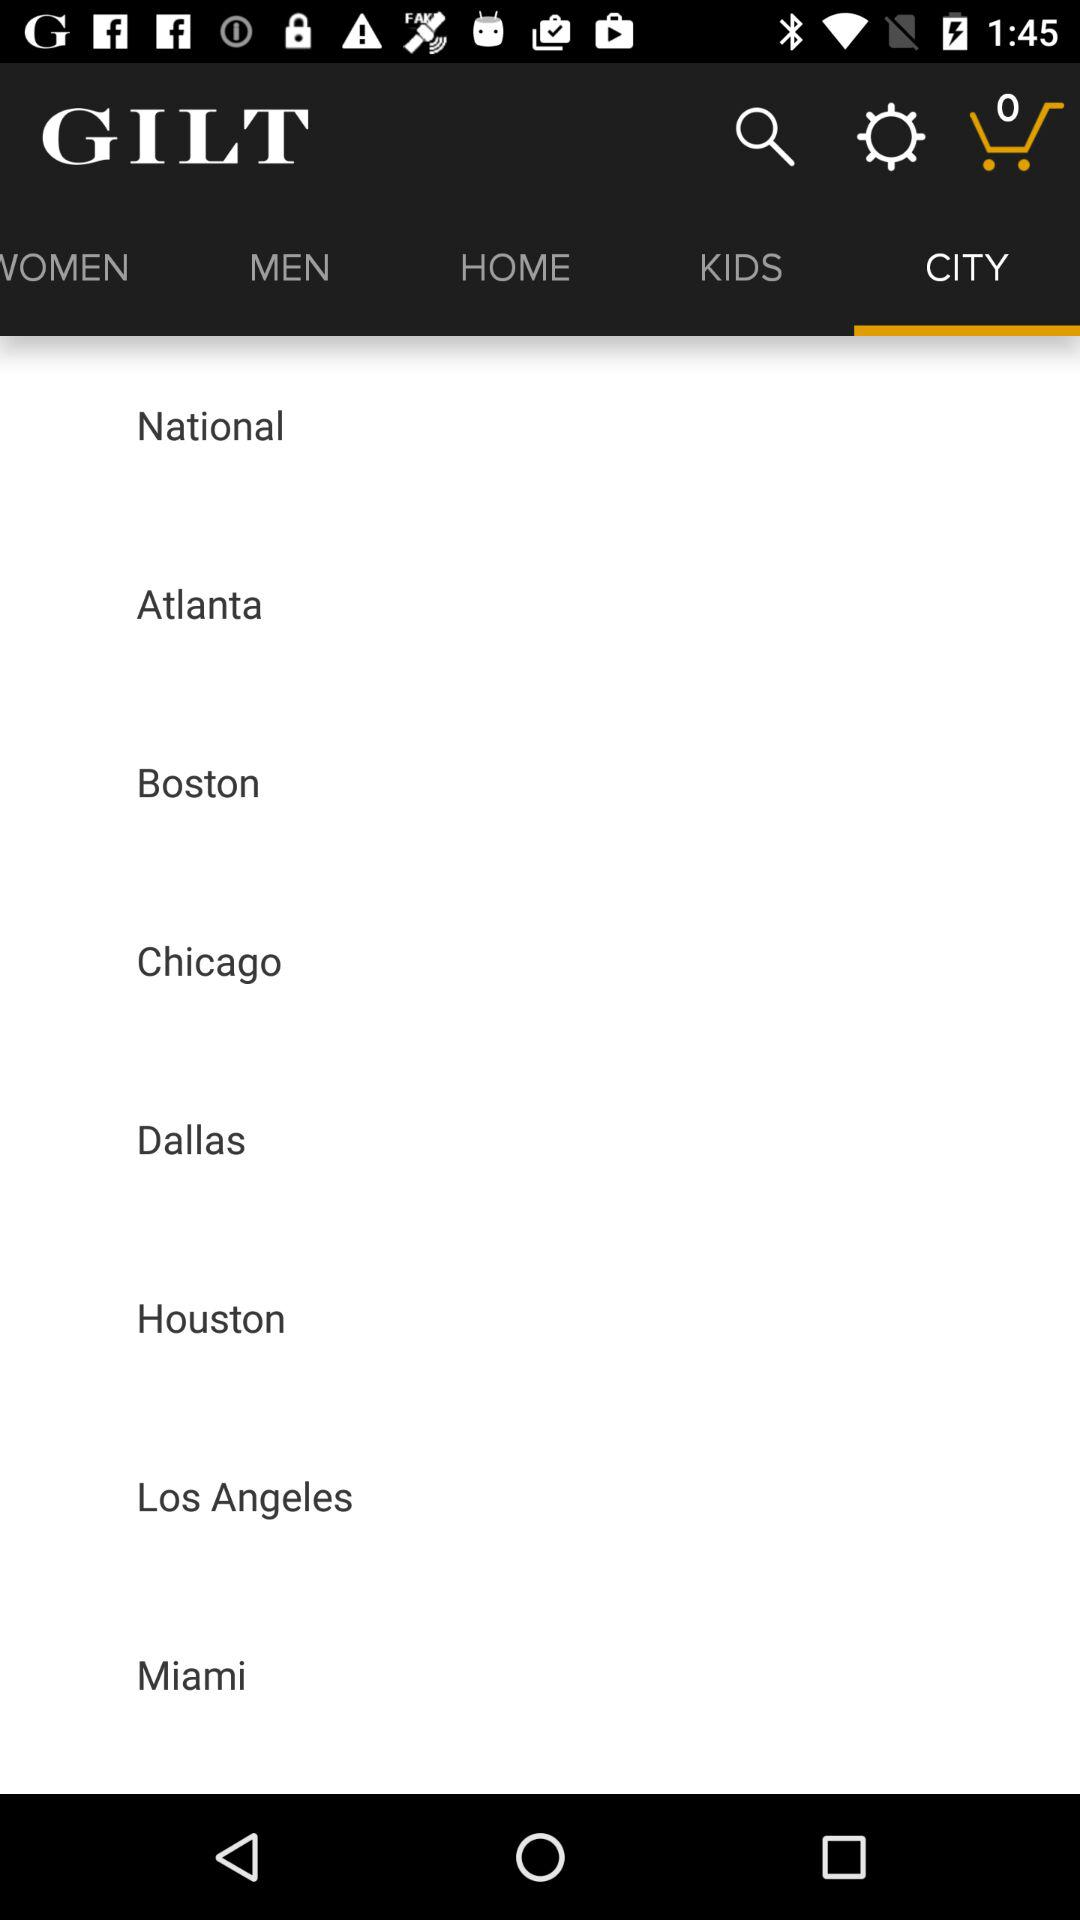How many name of city in this?
When the provided information is insufficient, respond with <no answer>. <no answer> 